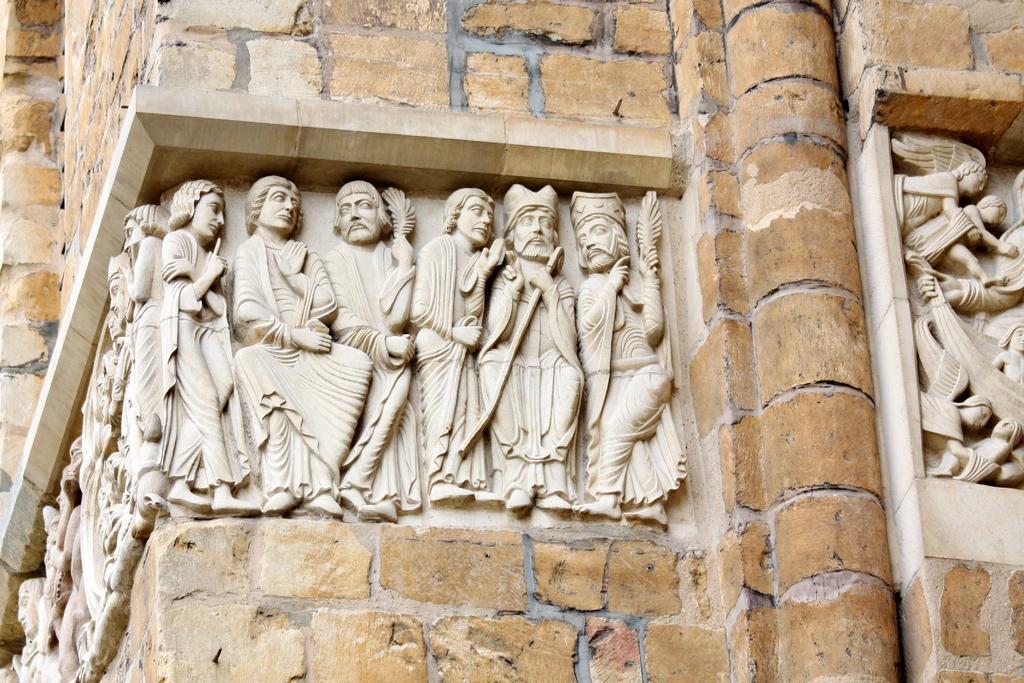Can you describe this image briefly? In this image in the center there are some sculptures, and there is a wall. 